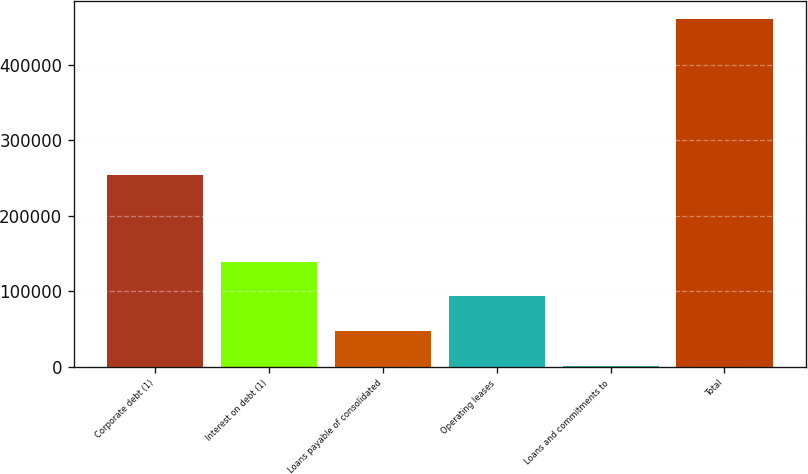Convert chart to OTSL. <chart><loc_0><loc_0><loc_500><loc_500><bar_chart><fcel>Corporate debt (1)<fcel>Interest on debt (1)<fcel>Loans payable of consolidated<fcel>Operating leases<fcel>Loans and commitments to<fcel>Total<nl><fcel>253970<fcel>139259<fcel>47282.2<fcel>93270.4<fcel>1294<fcel>461176<nl></chart> 